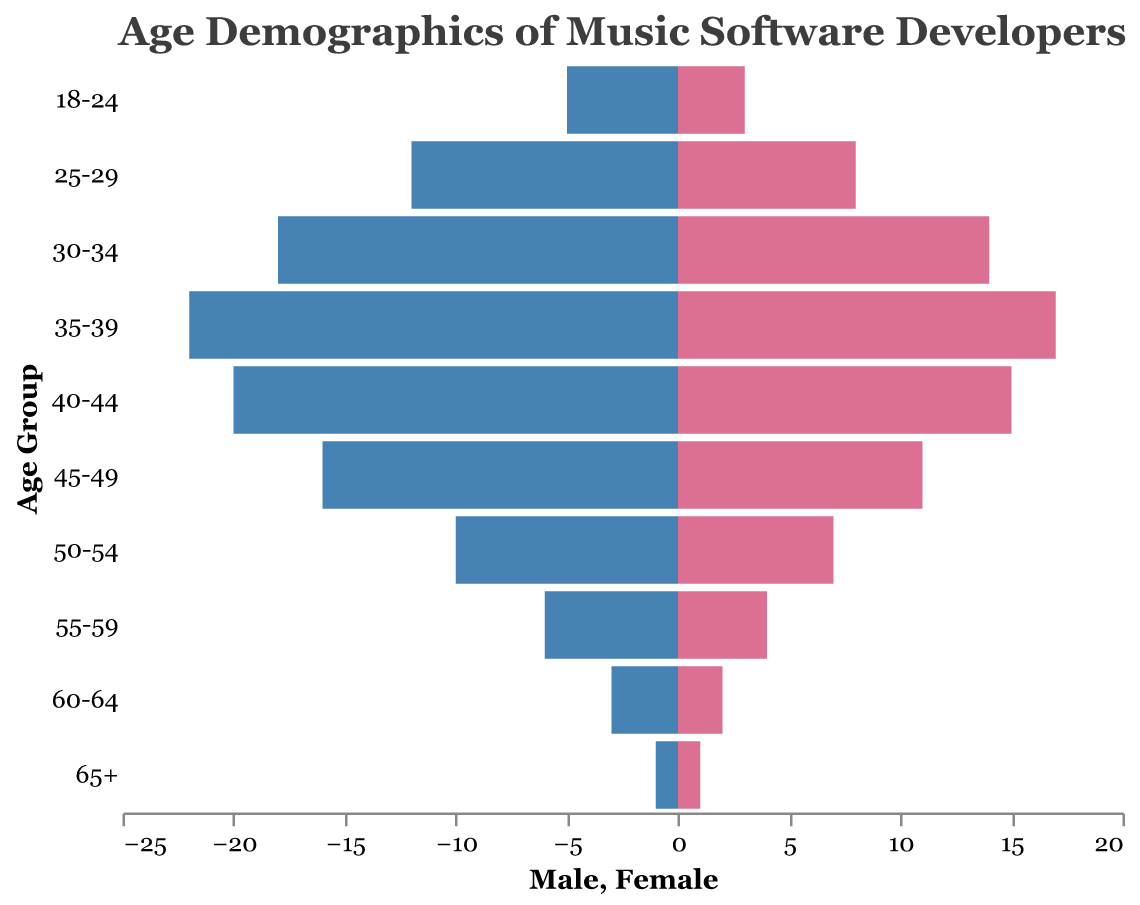What is the age group with the highest number of male music software developers? Look at the bar lengths on the left side (Male) and identify the longest bar, which corresponds to the age group 35-39.
Answer: 35-39 How many female developers are there in the age group 50-54? Locate the Female bar corresponding to the age group 50-54 on the right side and read its value, which is 7.
Answer: 7 Which gender has more developers in the age group 40-44? Compare the lengths of the Male (left) and Female (right) bars for the age group 40-44. The Male bar is longer, indicating that there are more male developers.
Answer: Male What is the total number of developers in the age group 30-34? Sum the number of male and female developers in the age group 30-34 (18 males + 14 females) to get the total.
Answer: 32 Which age group has an equal number of male and female developers? Check for an age group where the lengths of the Male and Female bars are identical. This occurs in the 65+ age group.
Answer: 65+ How many male developers are there in the age group 25-29? Locate the Male bar corresponding to the age group 25-29 on the left side and read its value, which is 12.
Answer: 12 What is the total number of female developers across all age groups combined? Add up the values of all the Female bars (3 + 8 + 14 + 17 + 15 + 11 + 7 + 4 + 2 + 1) to get the total. The sum is 82.
Answer: 82 Which age group shows the highest proportion of male developers compared to female developers? Analyze the ratio of male to female developers for each age group. The 18-24 age group has 5 males and 3 females, giving a higher male-to-female ratio compared to other age groups.
Answer: 18-24 Do more developers fall in the age range of 35-39 than in the range 45-49? Compare the total numbers of developers in the age groups 35-39 (22 males + 17 females = 39 total) and 45-49 (16 males + 11 females = 27 total). The 35-39 age group has more developers.
Answer: Yes 